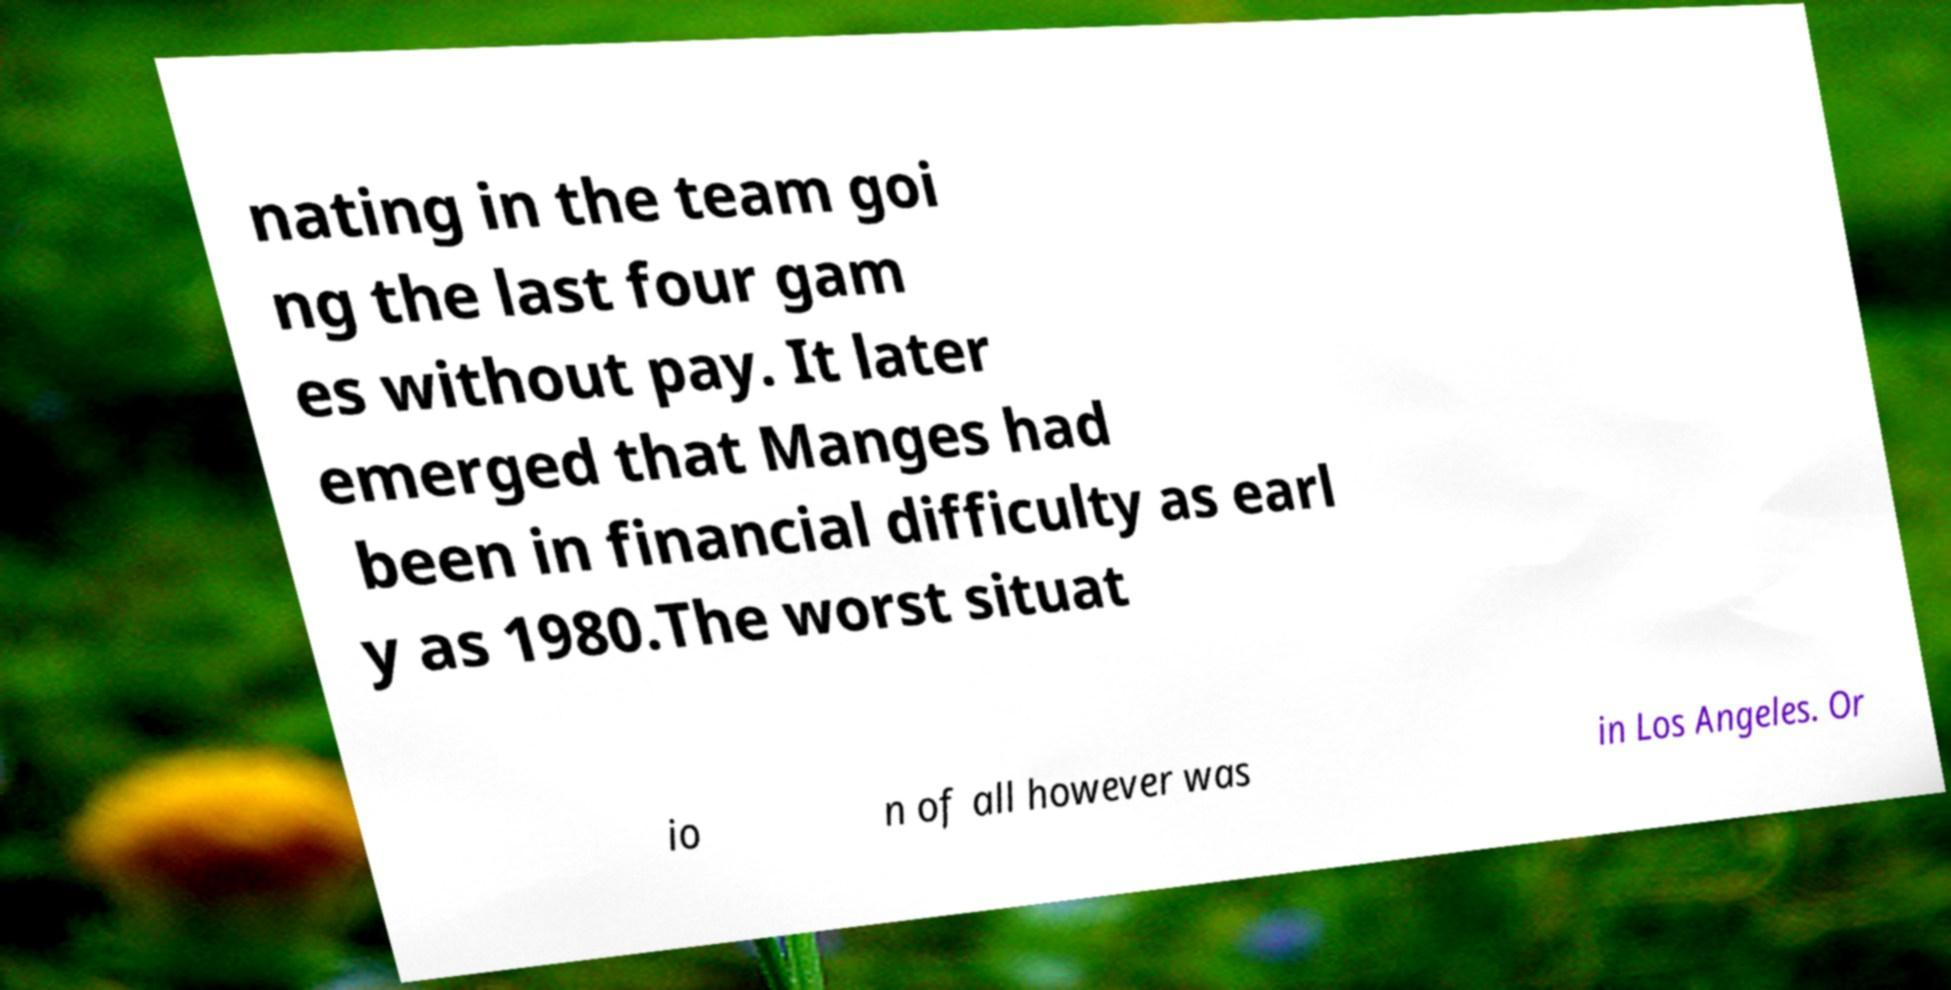Can you read and provide the text displayed in the image?This photo seems to have some interesting text. Can you extract and type it out for me? nating in the team goi ng the last four gam es without pay. It later emerged that Manges had been in financial difficulty as earl y as 1980.The worst situat io n of all however was in Los Angeles. Or 